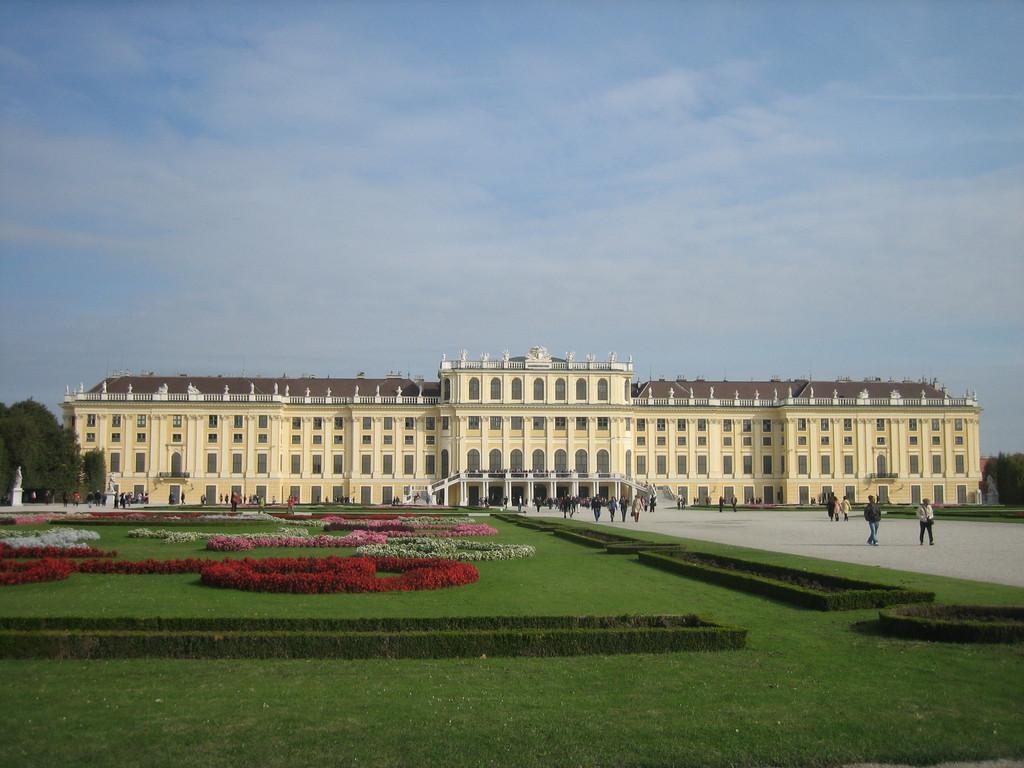In one or two sentences, can you explain what this image depicts? In this image we can see the front view of a building, in front of the building we can see grass lawn and pavement, there are few people walking on the pavement, beside the building there are trees, at the top of the image in the sky there are clouds. 